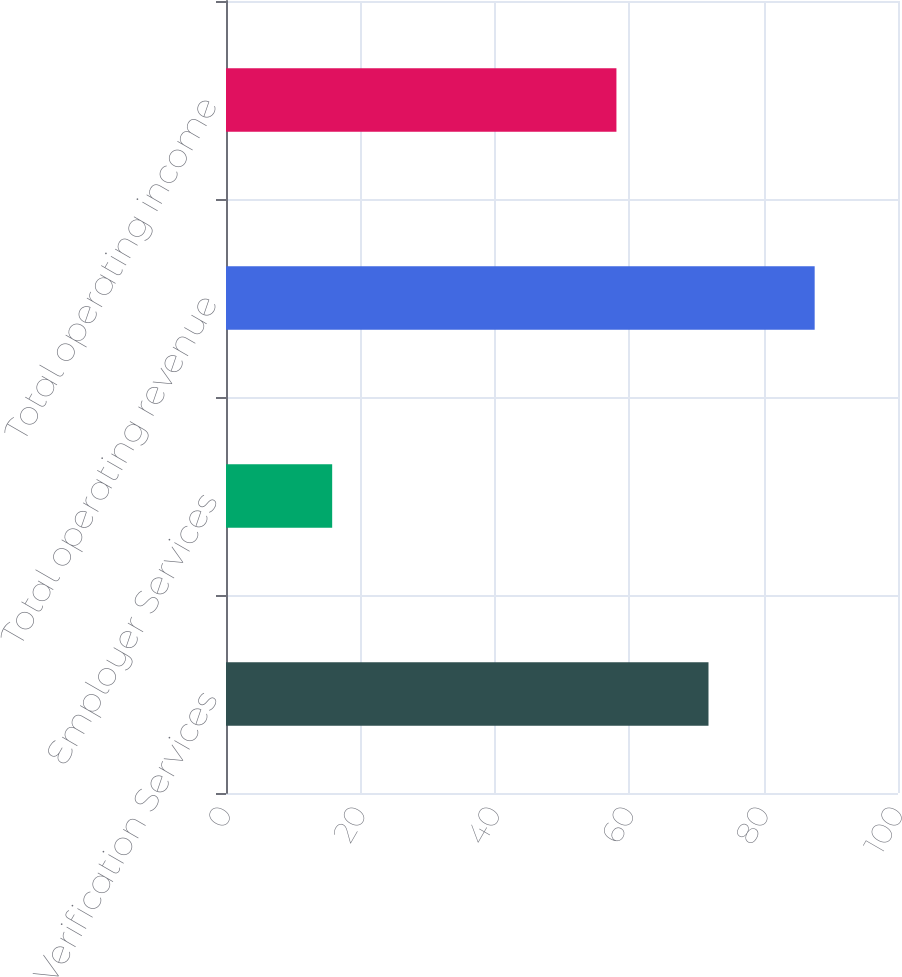<chart> <loc_0><loc_0><loc_500><loc_500><bar_chart><fcel>Verification Services<fcel>Employer Services<fcel>Total operating revenue<fcel>Total operating income<nl><fcel>71.8<fcel>15.8<fcel>87.6<fcel>58.1<nl></chart> 